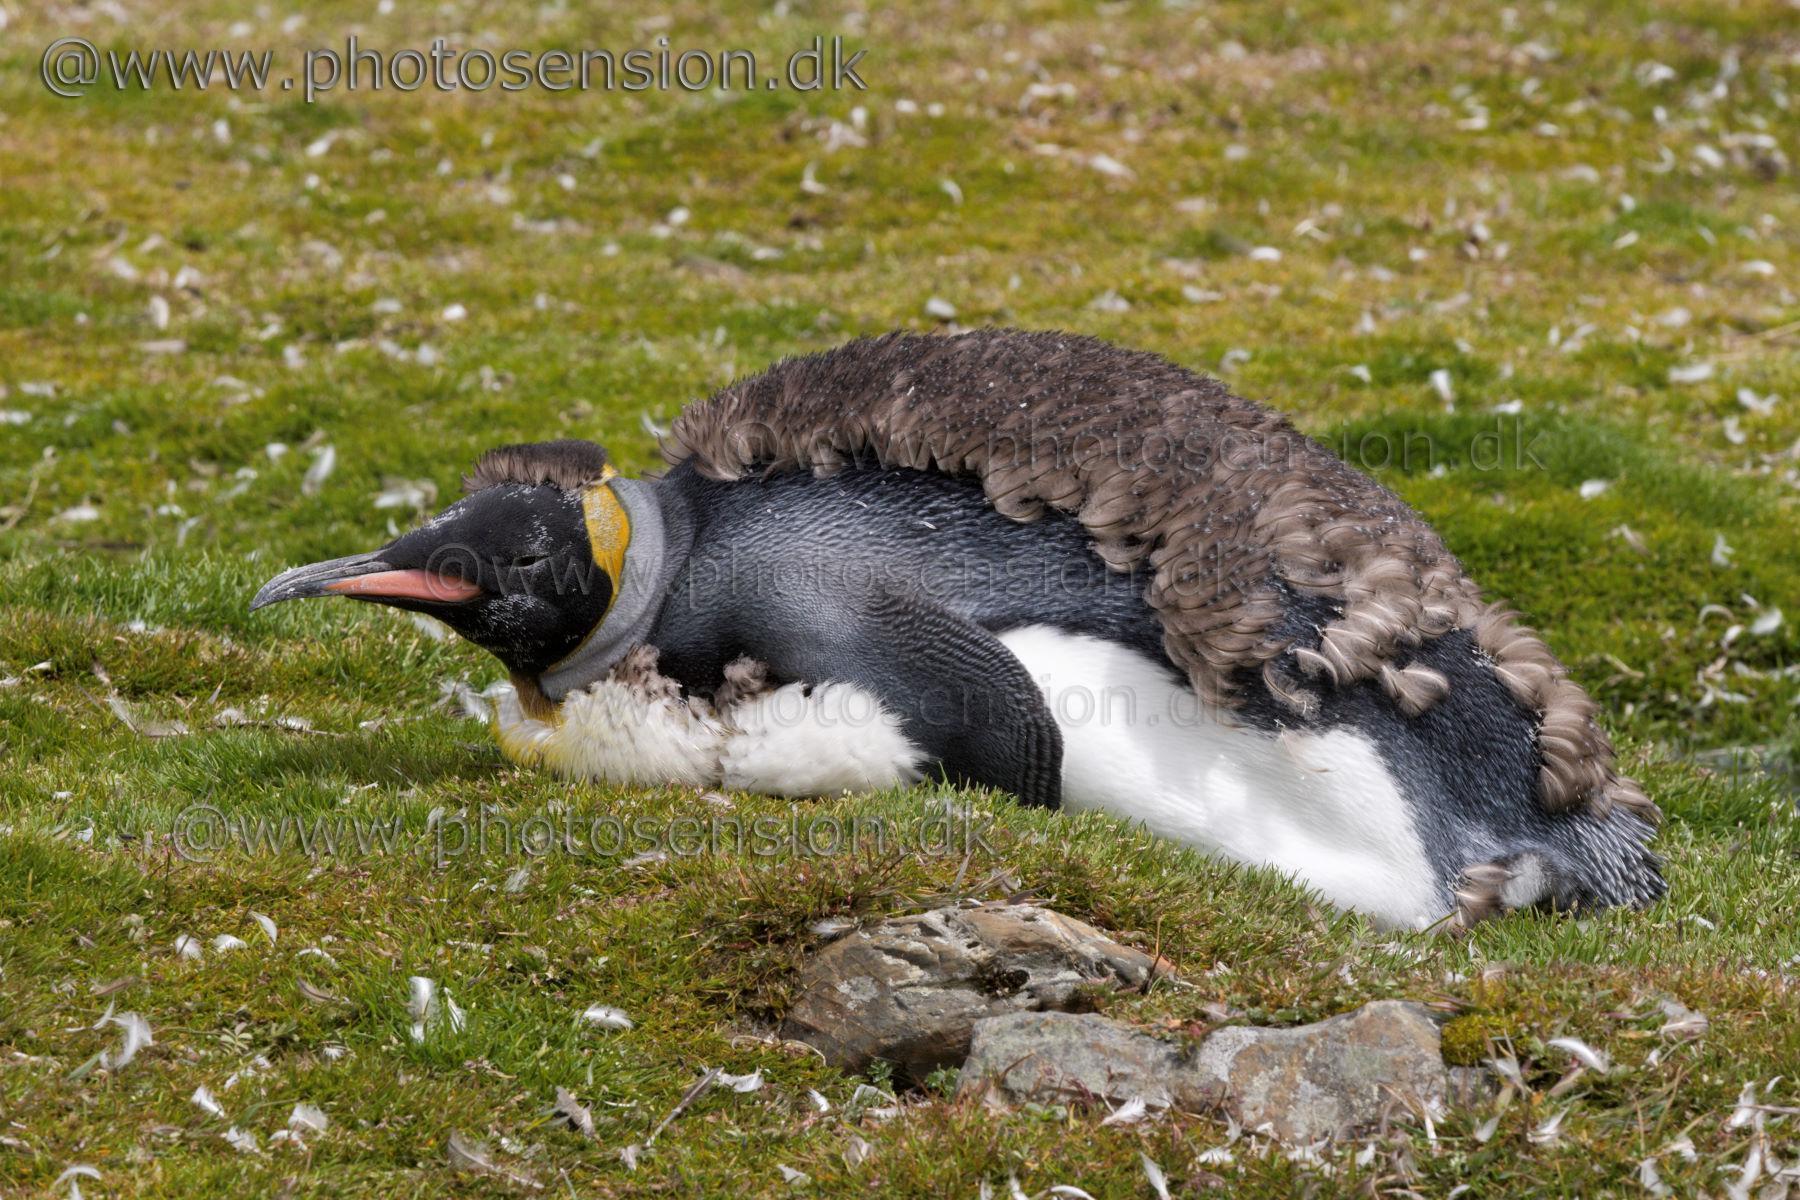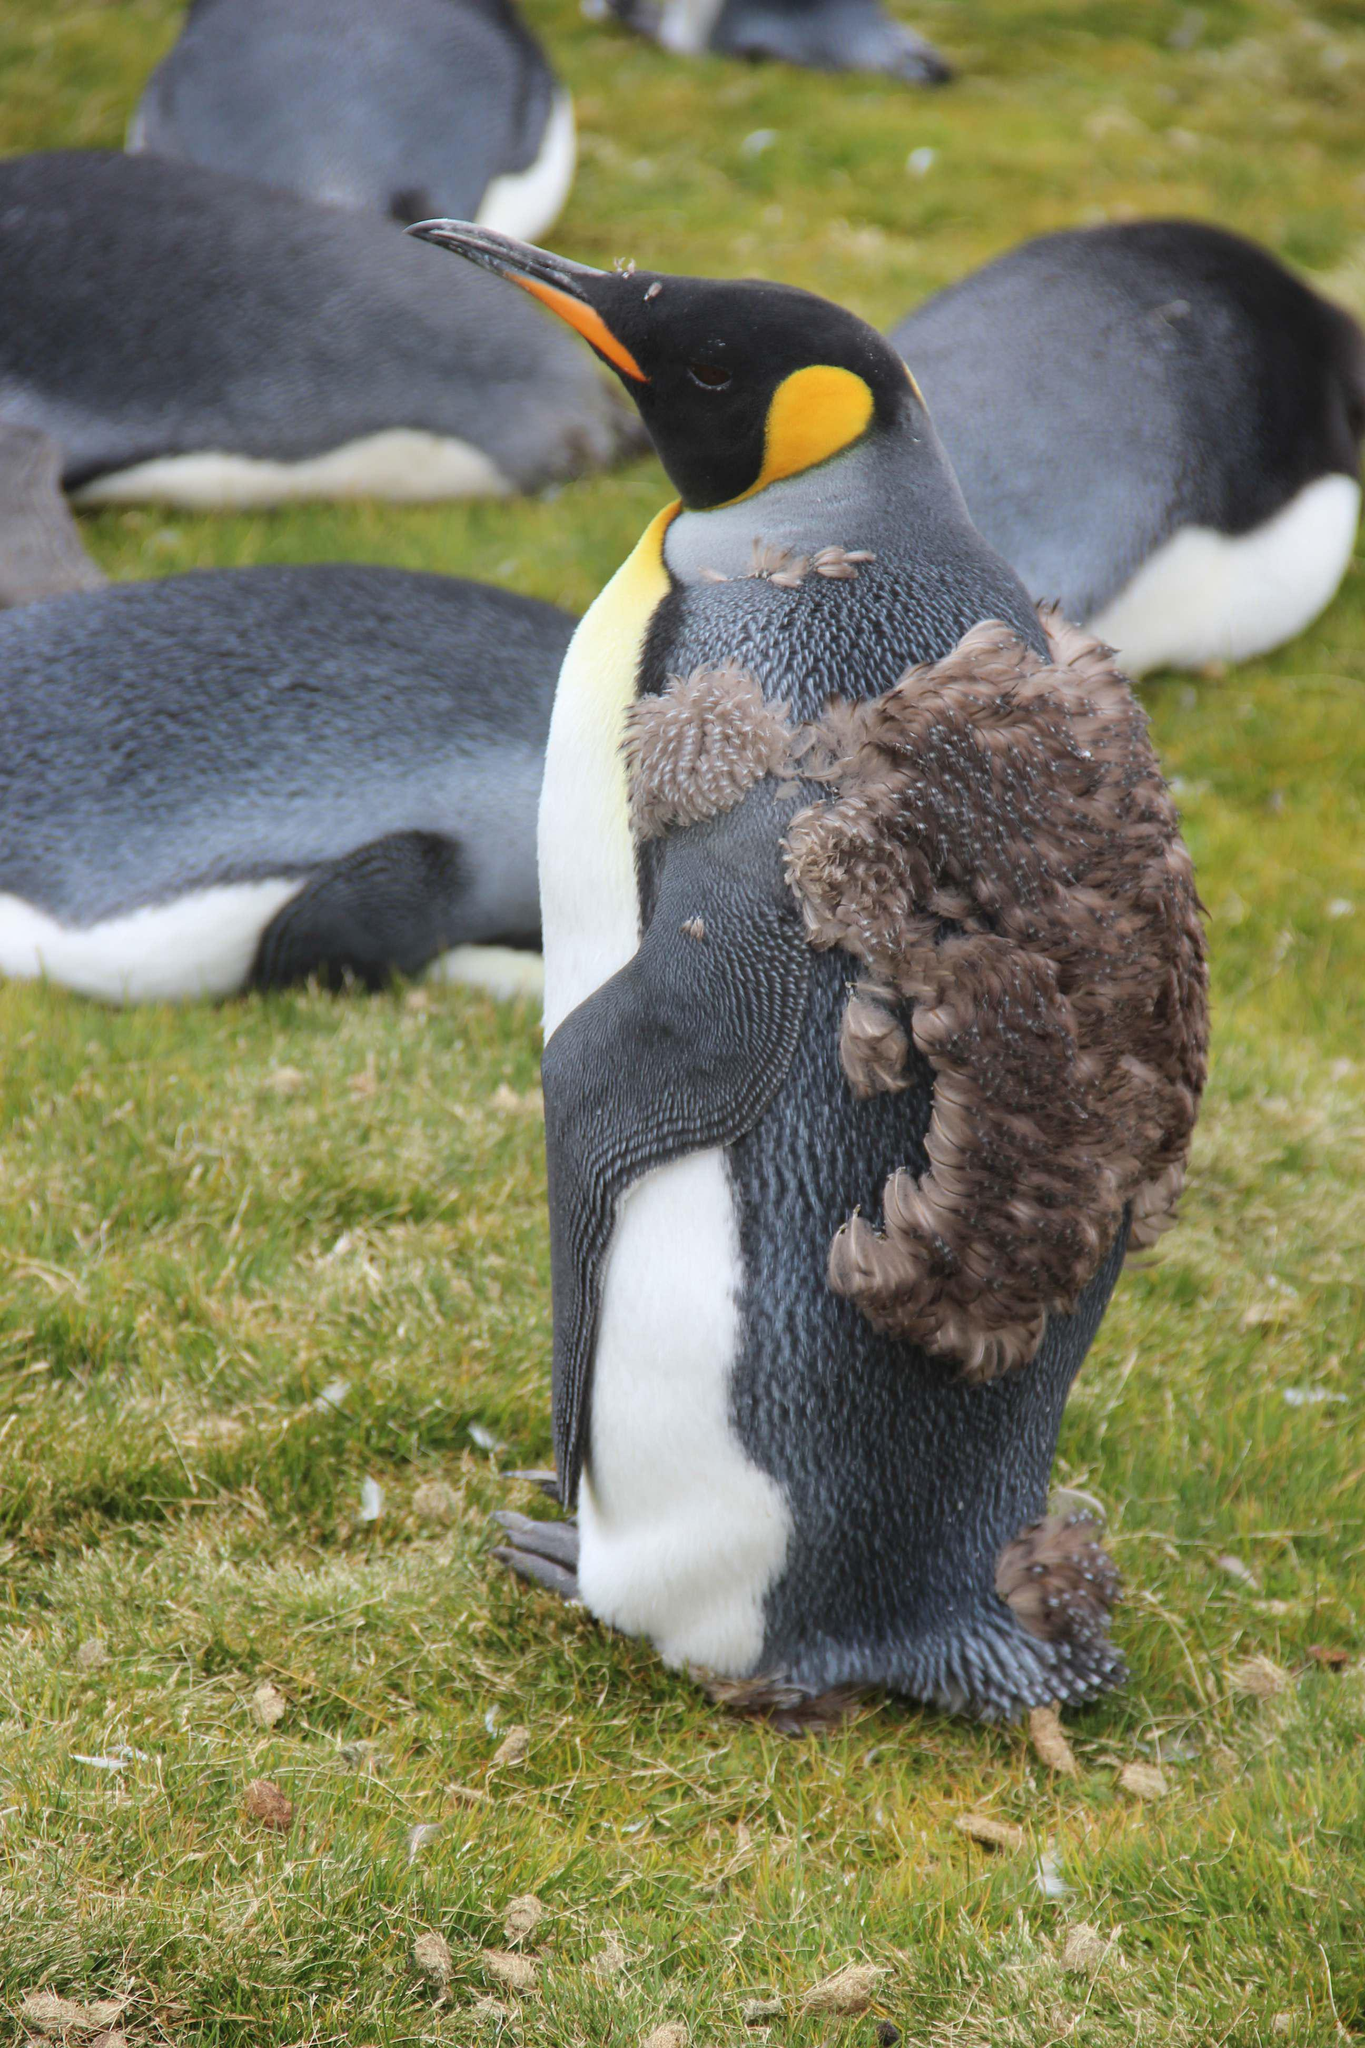The first image is the image on the left, the second image is the image on the right. Evaluate the accuracy of this statement regarding the images: "A sea lion is shown in one of the images.". Is it true? Answer yes or no. No. 